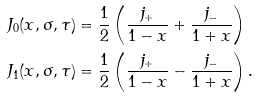Convert formula to latex. <formula><loc_0><loc_0><loc_500><loc_500>J _ { 0 } ( x , \sigma , \tau ) & = \frac { 1 } { 2 } \left ( \frac { j _ { + } } { 1 - x } + \frac { j _ { - } } { 1 + x } \right ) \\ J _ { 1 } ( x , \sigma , \tau ) & = \frac { 1 } { 2 } \left ( \frac { j _ { + } } { 1 - x } - \frac { j _ { - } } { 1 + x } \right ) .</formula> 